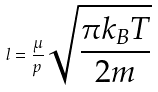Convert formula to latex. <formula><loc_0><loc_0><loc_500><loc_500>l = \frac { \mu } { p } \sqrt { \frac { \pi k _ { B } T } { 2 m } }</formula> 